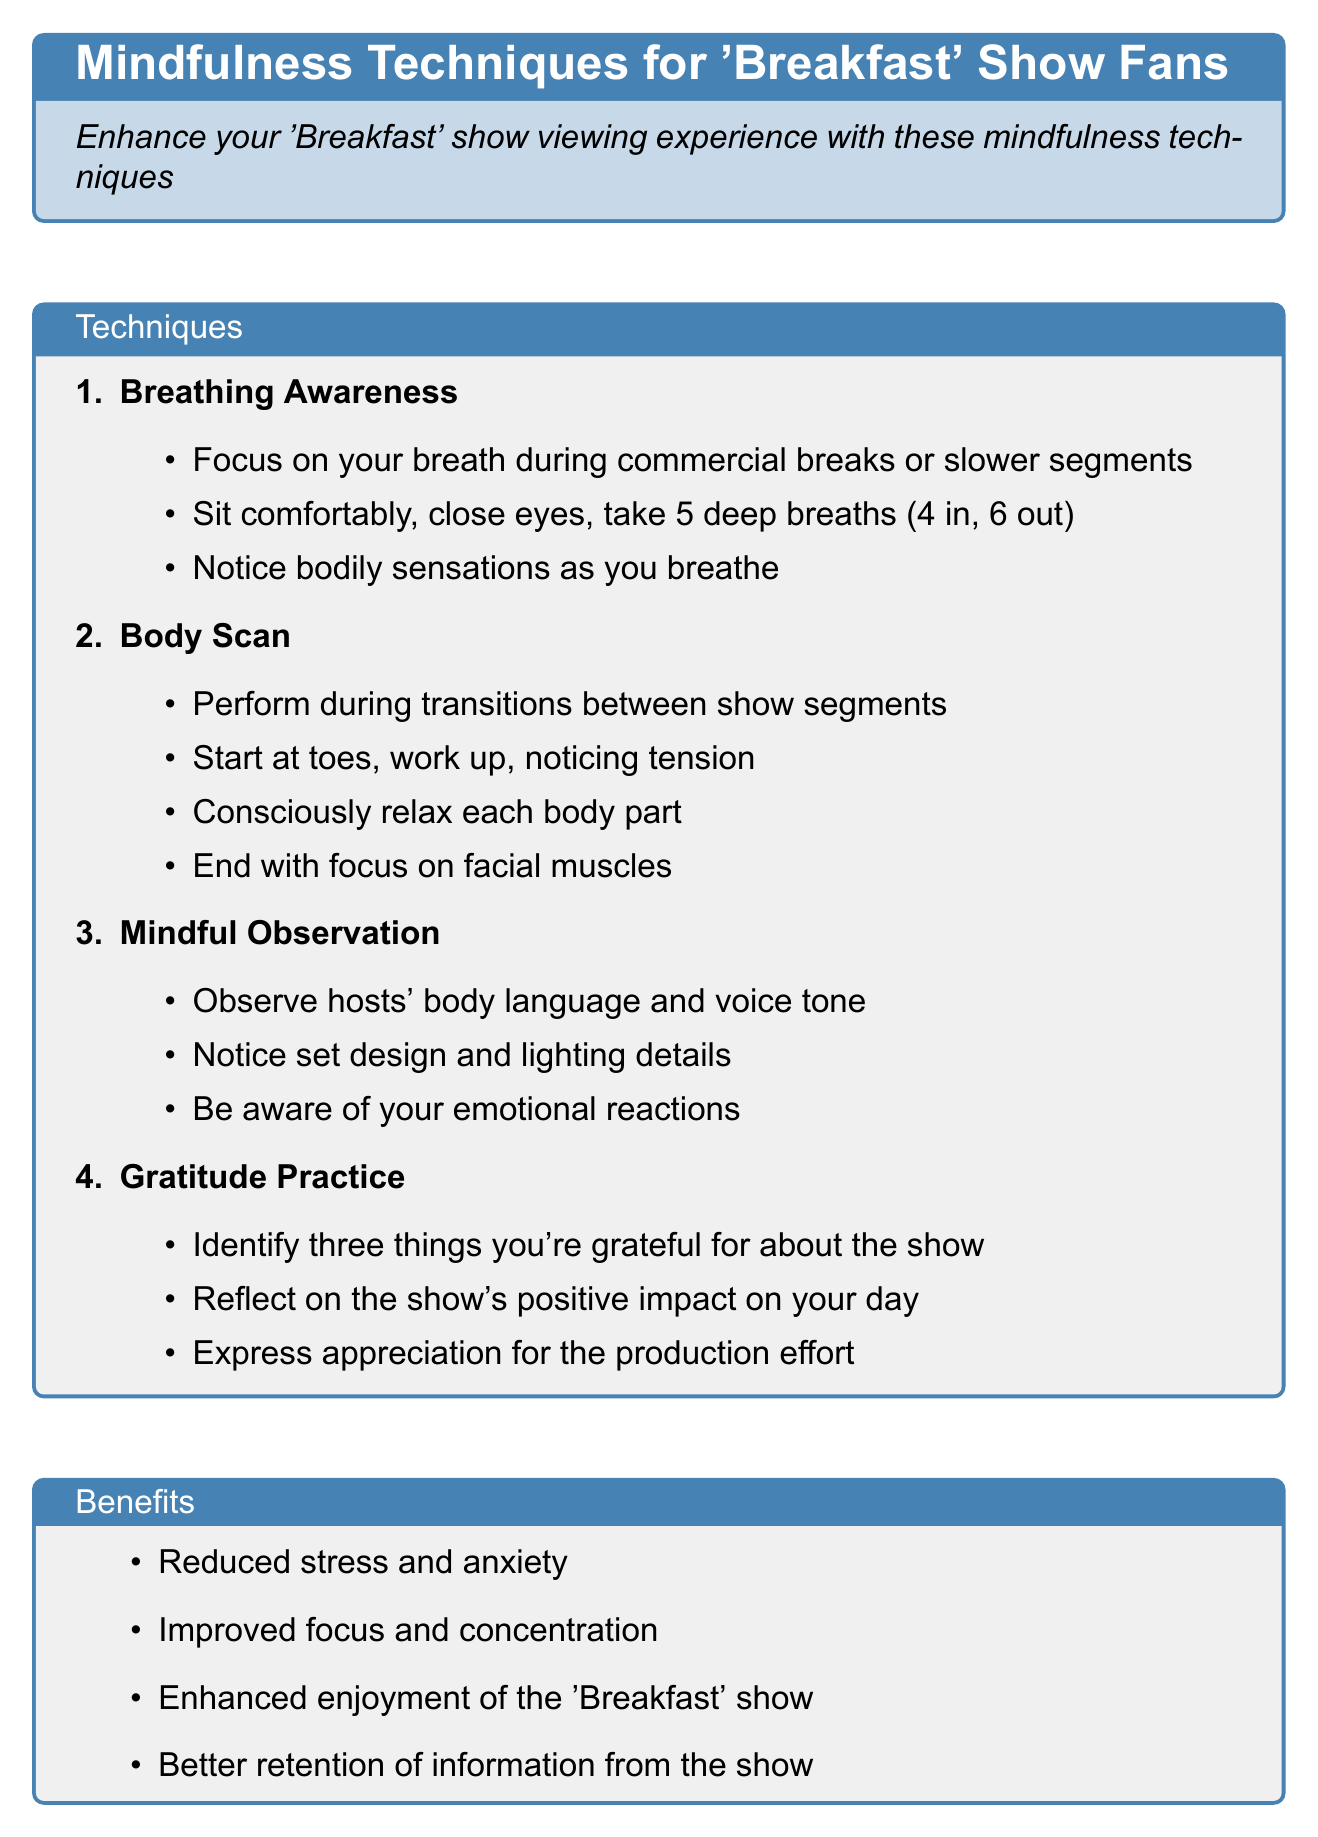What is the title of the document? The title is prominently displayed at the top of the document, marking the main topic of the notes.
Answer: Mindfulness Techniques for 'Breakfast' Show Fans How many mindfulness techniques are listed? The techniques are enumerated in a list format within the document, allowing for easy counting.
Answer: 4 What is the first technique mentioned? The first technique is specified in the numbered list, providing a clear reference for the content.
Answer: Breathing Awareness What is one benefit of practicing mindfulness while watching TV? Benefits are listed in a dedicated section, highlighting their positive effects.
Answer: Reduced stress and anxiety During which segments should breathing awareness be practiced? The description under the technique provides guidance on when to apply the specific technique.
Answer: Commercial breaks or slower segments What should you notice during a body scan? The steps for the body scan include specifics on what to pay attention to, enhancing the mindfulness practice.
Answer: Tension or discomfort What is suggested to identify during gratitude practice? The steps outline the focus of the gratitude exercise, emphasizing appreciation for the show.
Answer: Three things you're grateful for about the show What is the tip provided for incorporating these techniques? A specific tip section offers practical advice for viewers on how to implement the mindfulness practices.
Answer: Try incorporating one technique per viewing session 